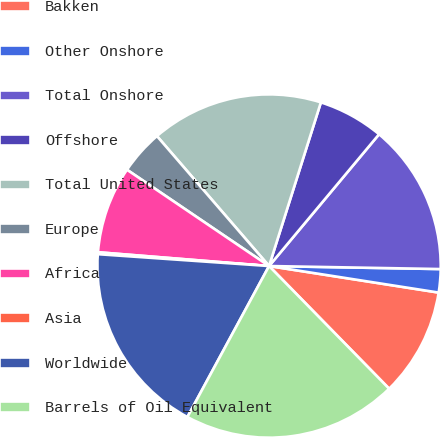<chart> <loc_0><loc_0><loc_500><loc_500><pie_chart><fcel>Bakken<fcel>Other Onshore<fcel>Total Onshore<fcel>Offshore<fcel>Total United States<fcel>Europe<fcel>Africa<fcel>Asia<fcel>Worldwide<fcel>Barrels of Oil Equivalent<nl><fcel>10.2%<fcel>2.19%<fcel>14.21%<fcel>6.19%<fcel>16.21%<fcel>4.19%<fcel>8.2%<fcel>0.18%<fcel>18.21%<fcel>20.22%<nl></chart> 